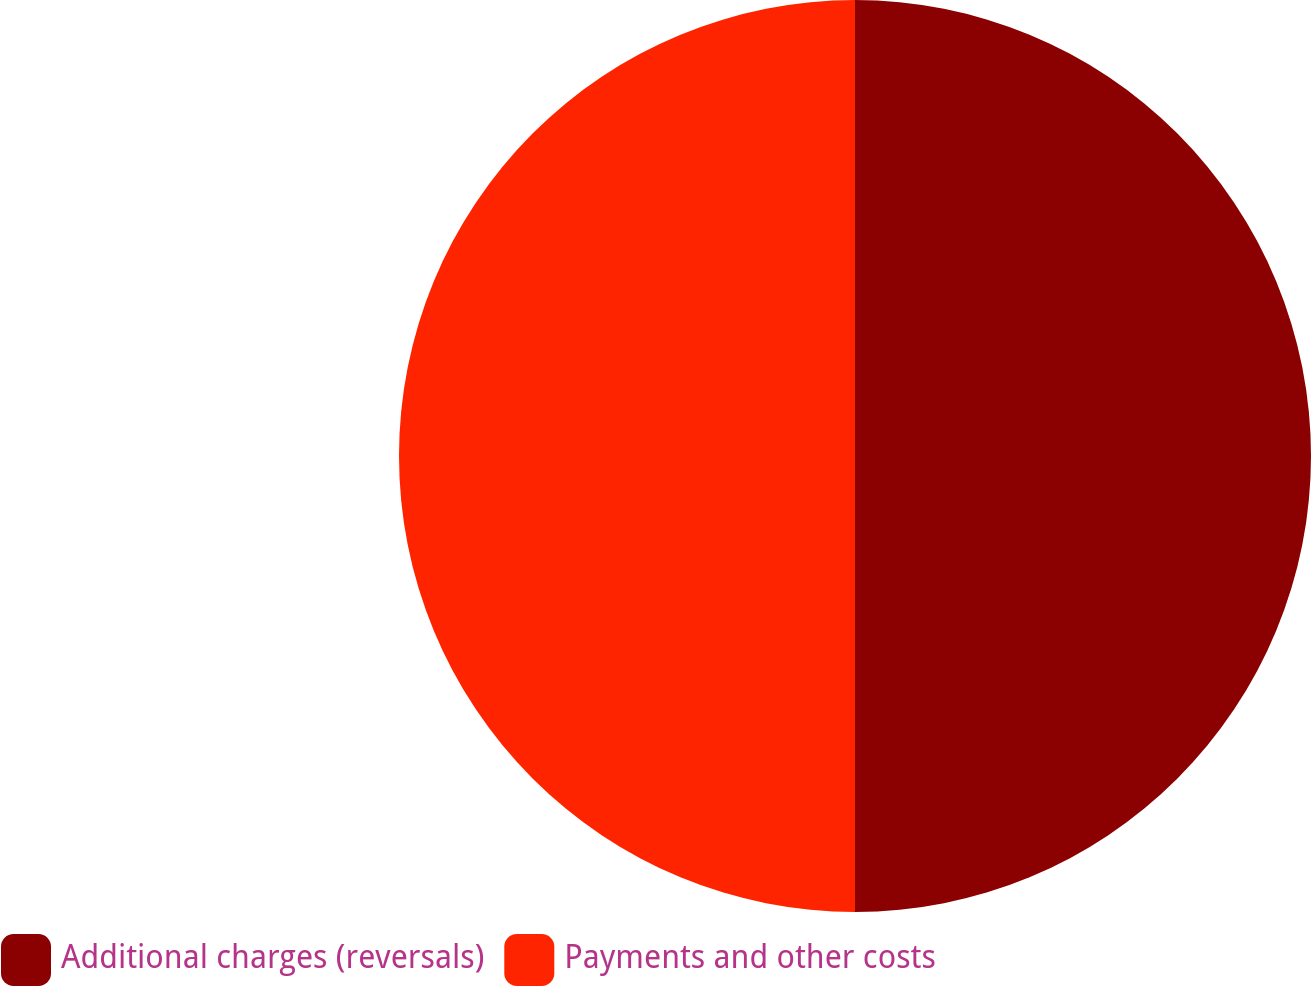Convert chart to OTSL. <chart><loc_0><loc_0><loc_500><loc_500><pie_chart><fcel>Additional charges (reversals)<fcel>Payments and other costs<nl><fcel>50.0%<fcel>50.0%<nl></chart> 